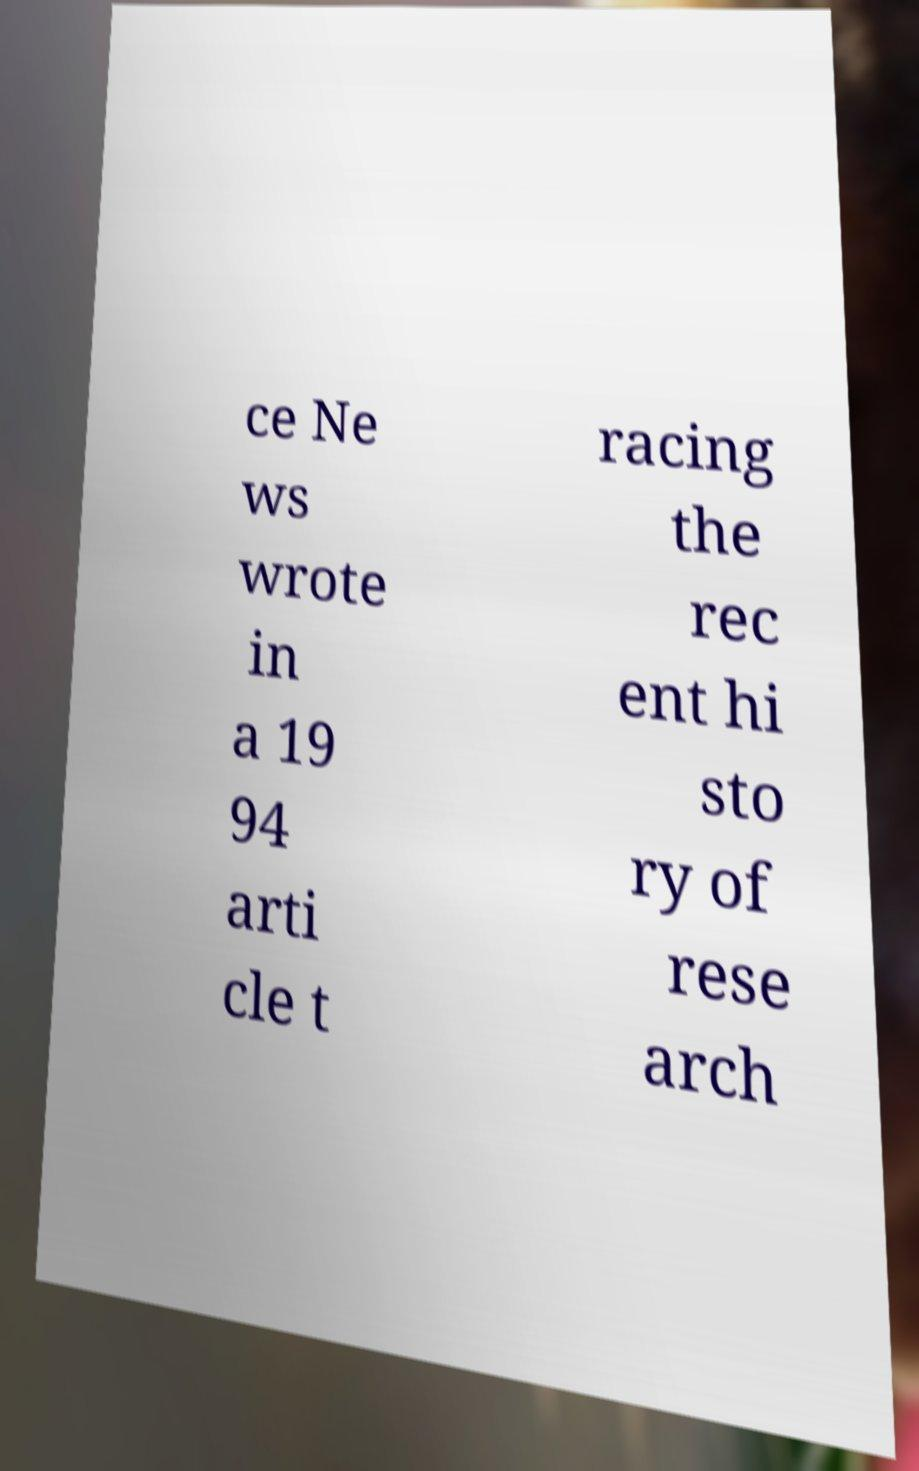I need the written content from this picture converted into text. Can you do that? ce Ne ws wrote in a 19 94 arti cle t racing the rec ent hi sto ry of rese arch 